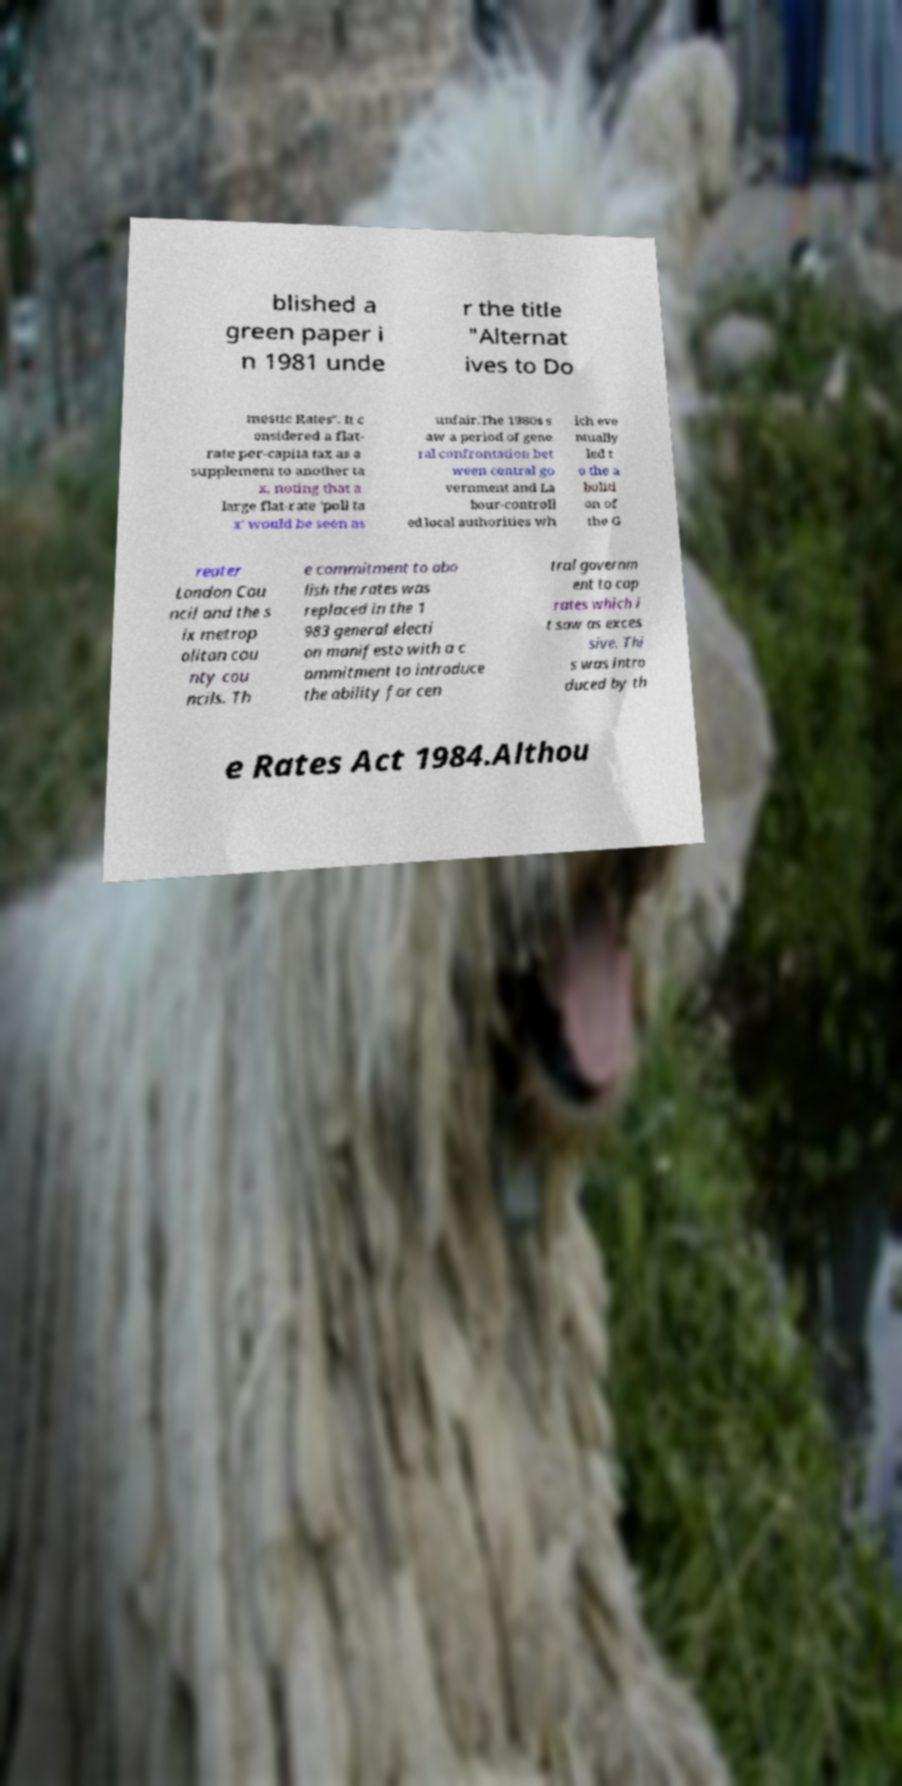I need the written content from this picture converted into text. Can you do that? blished a green paper i n 1981 unde r the title "Alternat ives to Do mestic Rates". It c onsidered a flat- rate per-capita tax as a supplement to another ta x, noting that a large flat-rate 'poll ta x' would be seen as unfair.The 1980s s aw a period of gene ral confrontation bet ween central go vernment and La bour-controll ed local authorities wh ich eve ntually led t o the a boliti on of the G reater London Cou ncil and the s ix metrop olitan cou nty cou ncils. Th e commitment to abo lish the rates was replaced in the 1 983 general electi on manifesto with a c ommitment to introduce the ability for cen tral governm ent to cap rates which i t saw as exces sive. Thi s was intro duced by th e Rates Act 1984.Althou 